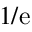<formula> <loc_0><loc_0><loc_500><loc_500>1 / e</formula> 